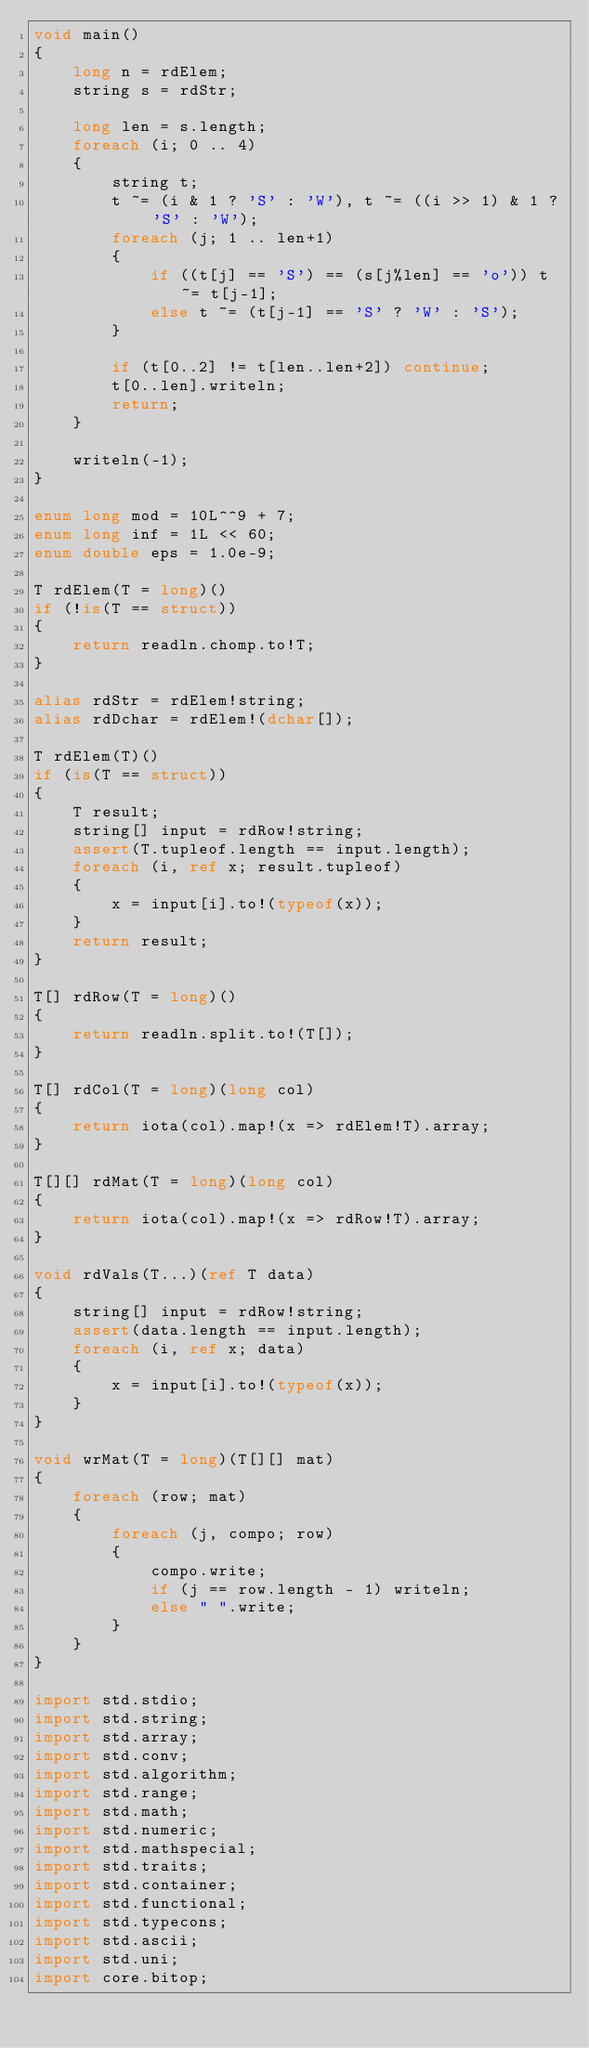Convert code to text. <code><loc_0><loc_0><loc_500><loc_500><_D_>void main()
{
    long n = rdElem;
    string s = rdStr;

    long len = s.length;
    foreach (i; 0 .. 4)
    {
        string t;
        t ~= (i & 1 ? 'S' : 'W'), t ~= ((i >> 1) & 1 ? 'S' : 'W');
        foreach (j; 1 .. len+1)
        {
            if ((t[j] == 'S') == (s[j%len] == 'o')) t ~= t[j-1];
            else t ~= (t[j-1] == 'S' ? 'W' : 'S');
        }

        if (t[0..2] != t[len..len+2]) continue;
        t[0..len].writeln;
        return;
    }

    writeln(-1);
}

enum long mod = 10L^^9 + 7;
enum long inf = 1L << 60;
enum double eps = 1.0e-9;

T rdElem(T = long)()
if (!is(T == struct))
{
    return readln.chomp.to!T;
}

alias rdStr = rdElem!string;
alias rdDchar = rdElem!(dchar[]);

T rdElem(T)()
if (is(T == struct))
{
    T result;
    string[] input = rdRow!string;
    assert(T.tupleof.length == input.length);
    foreach (i, ref x; result.tupleof)
    {
        x = input[i].to!(typeof(x));
    }
    return result;
}

T[] rdRow(T = long)()
{
    return readln.split.to!(T[]);
}

T[] rdCol(T = long)(long col)
{
    return iota(col).map!(x => rdElem!T).array;
}

T[][] rdMat(T = long)(long col)
{
    return iota(col).map!(x => rdRow!T).array;
}

void rdVals(T...)(ref T data)
{
    string[] input = rdRow!string;
    assert(data.length == input.length);
    foreach (i, ref x; data)
    {
        x = input[i].to!(typeof(x));
    }
}

void wrMat(T = long)(T[][] mat)
{
    foreach (row; mat)
    {
        foreach (j, compo; row)
        {
            compo.write;
            if (j == row.length - 1) writeln;
            else " ".write;
        }
    }
}

import std.stdio;
import std.string;
import std.array;
import std.conv;
import std.algorithm;
import std.range;
import std.math;
import std.numeric;
import std.mathspecial;
import std.traits;
import std.container;
import std.functional;
import std.typecons;
import std.ascii;
import std.uni;
import core.bitop;</code> 